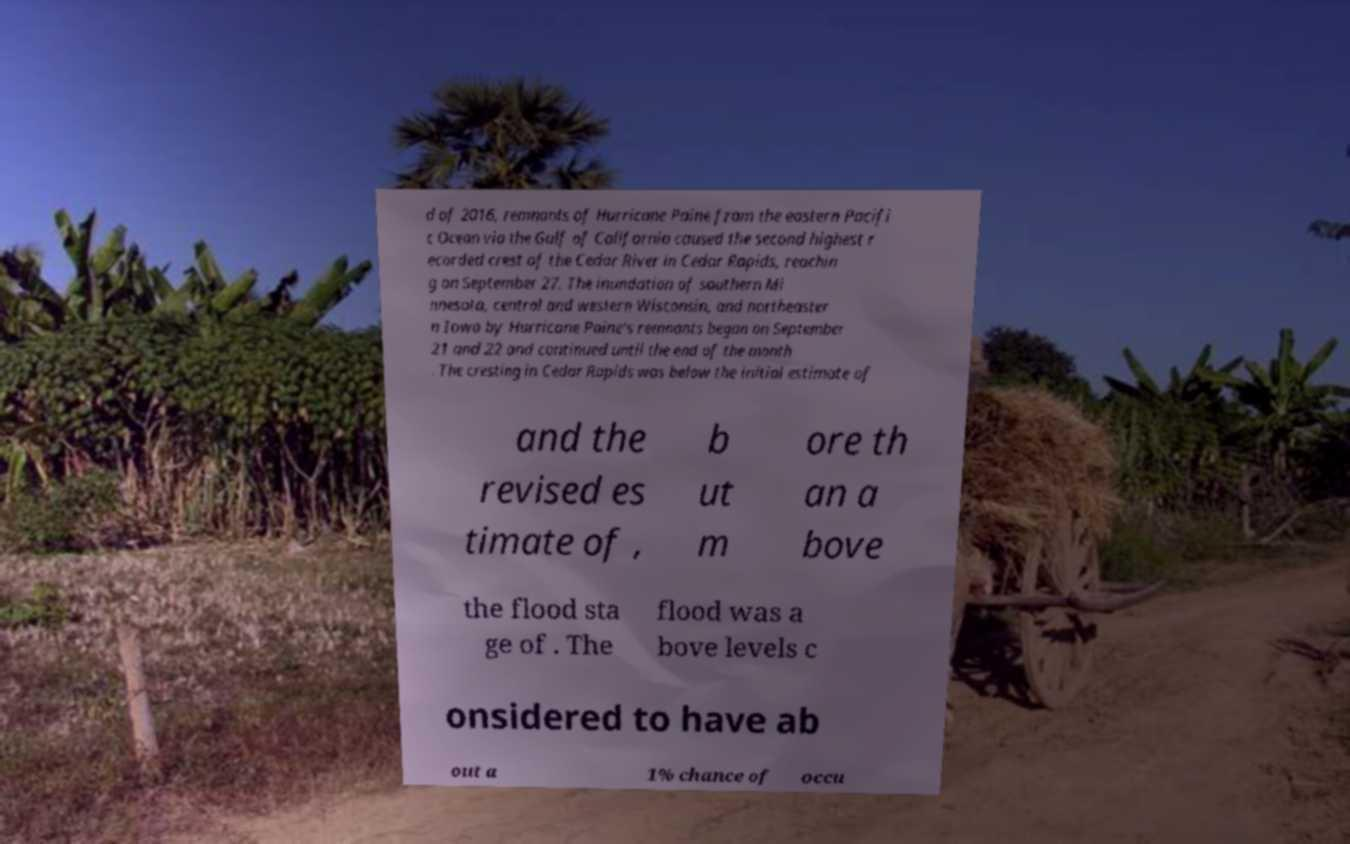Can you read and provide the text displayed in the image?This photo seems to have some interesting text. Can you extract and type it out for me? d of 2016, remnants of Hurricane Paine from the eastern Pacifi c Ocean via the Gulf of California caused the second highest r ecorded crest of the Cedar River in Cedar Rapids, reachin g on September 27. The inundation of southern Mi nnesota, central and western Wisconsin, and northeaster n Iowa by Hurricane Paine's remnants began on September 21 and 22 and continued until the end of the month . The cresting in Cedar Rapids was below the initial estimate of and the revised es timate of , b ut m ore th an a bove the flood sta ge of . The flood was a bove levels c onsidered to have ab out a 1% chance of occu 